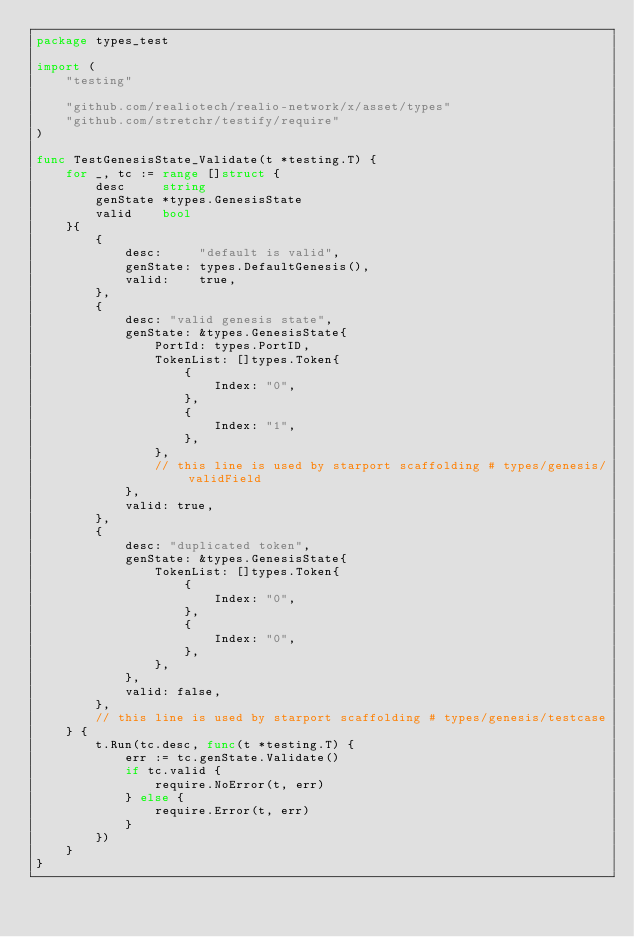<code> <loc_0><loc_0><loc_500><loc_500><_Go_>package types_test

import (
	"testing"

	"github.com/realiotech/realio-network/x/asset/types"
	"github.com/stretchr/testify/require"
)

func TestGenesisState_Validate(t *testing.T) {
	for _, tc := range []struct {
		desc     string
		genState *types.GenesisState
		valid    bool
	}{
		{
			desc:     "default is valid",
			genState: types.DefaultGenesis(),
			valid:    true,
		},
		{
			desc: "valid genesis state",
			genState: &types.GenesisState{
				PortId: types.PortID,
				TokenList: []types.Token{
					{
						Index: "0",
					},
					{
						Index: "1",
					},
				},
				// this line is used by starport scaffolding # types/genesis/validField
			},
			valid: true,
		},
		{
			desc: "duplicated token",
			genState: &types.GenesisState{
				TokenList: []types.Token{
					{
						Index: "0",
					},
					{
						Index: "0",
					},
				},
			},
			valid: false,
		},
		// this line is used by starport scaffolding # types/genesis/testcase
	} {
		t.Run(tc.desc, func(t *testing.T) {
			err := tc.genState.Validate()
			if tc.valid {
				require.NoError(t, err)
			} else {
				require.Error(t, err)
			}
		})
	}
}
</code> 